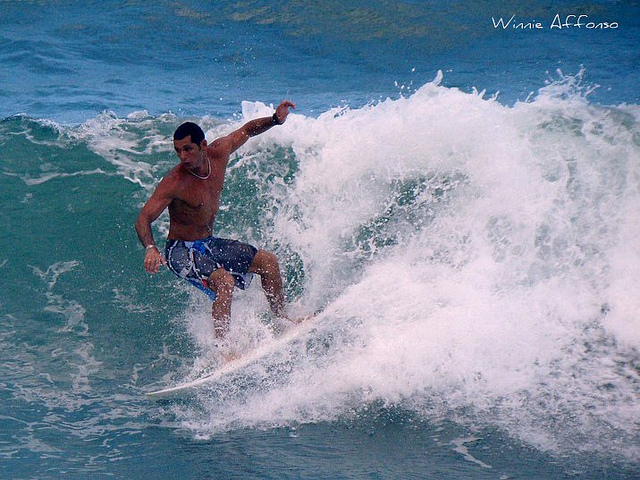Identify the text displayed in this image. Winnie Affonso 